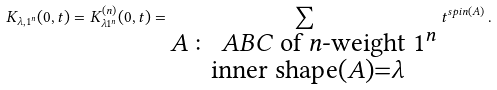<formula> <loc_0><loc_0><loc_500><loc_500>K _ { \lambda , 1 ^ { n } } ( 0 , t ) = K _ { \lambda 1 ^ { n } } ^ { ( n ) } ( 0 , t ) = \sum _ { \substack { A \colon \text { $ABC$ of $n$-weight $1^{n}$} \\ \ \text {inner shape} ( A ) = \lambda } } t ^ { s p i n ( A ) } \, .</formula> 